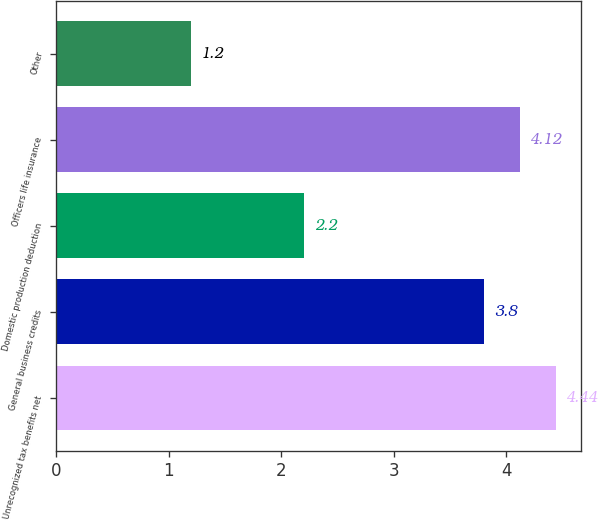Convert chart. <chart><loc_0><loc_0><loc_500><loc_500><bar_chart><fcel>Unrecognized tax benefits net<fcel>General business credits<fcel>Domestic production deduction<fcel>Officers life insurance<fcel>Other<nl><fcel>4.44<fcel>3.8<fcel>2.2<fcel>4.12<fcel>1.2<nl></chart> 